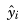Convert formula to latex. <formula><loc_0><loc_0><loc_500><loc_500>\hat { y } _ { i }</formula> 